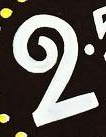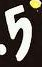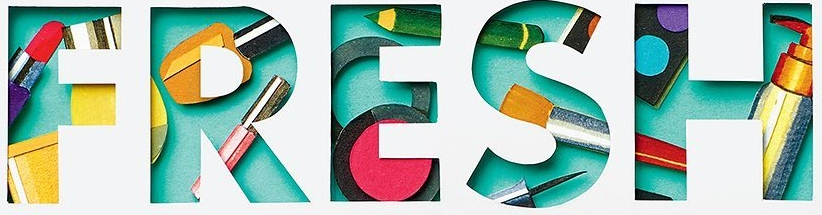Read the text content from these images in order, separated by a semicolon. 2; 5; FRESH 